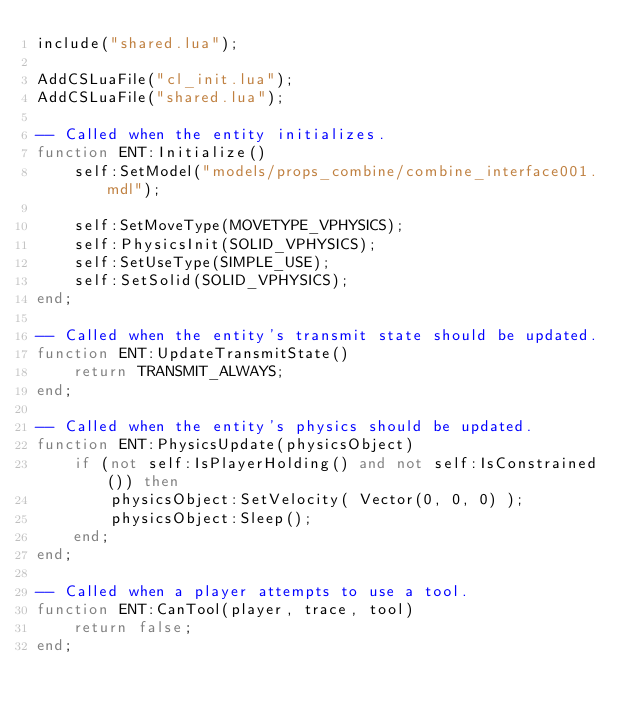Convert code to text. <code><loc_0><loc_0><loc_500><loc_500><_Lua_>include("shared.lua");

AddCSLuaFile("cl_init.lua");
AddCSLuaFile("shared.lua");

-- Called when the entity initializes.
function ENT:Initialize()
	self:SetModel("models/props_combine/combine_interface001.mdl");

	self:SetMoveType(MOVETYPE_VPHYSICS);
	self:PhysicsInit(SOLID_VPHYSICS);
	self:SetUseType(SIMPLE_USE);
	self:SetSolid(SOLID_VPHYSICS);
end;

-- Called when the entity's transmit state should be updated.
function ENT:UpdateTransmitState()
	return TRANSMIT_ALWAYS;
end;

-- Called when the entity's physics should be updated.
function ENT:PhysicsUpdate(physicsObject)
	if (not self:IsPlayerHolding() and not self:IsConstrained()) then
		physicsObject:SetVelocity( Vector(0, 0, 0) );
		physicsObject:Sleep();
	end;
end;

-- Called when a player attempts to use a tool.
function ENT:CanTool(player, trace, tool)
	return false;
end;
</code> 